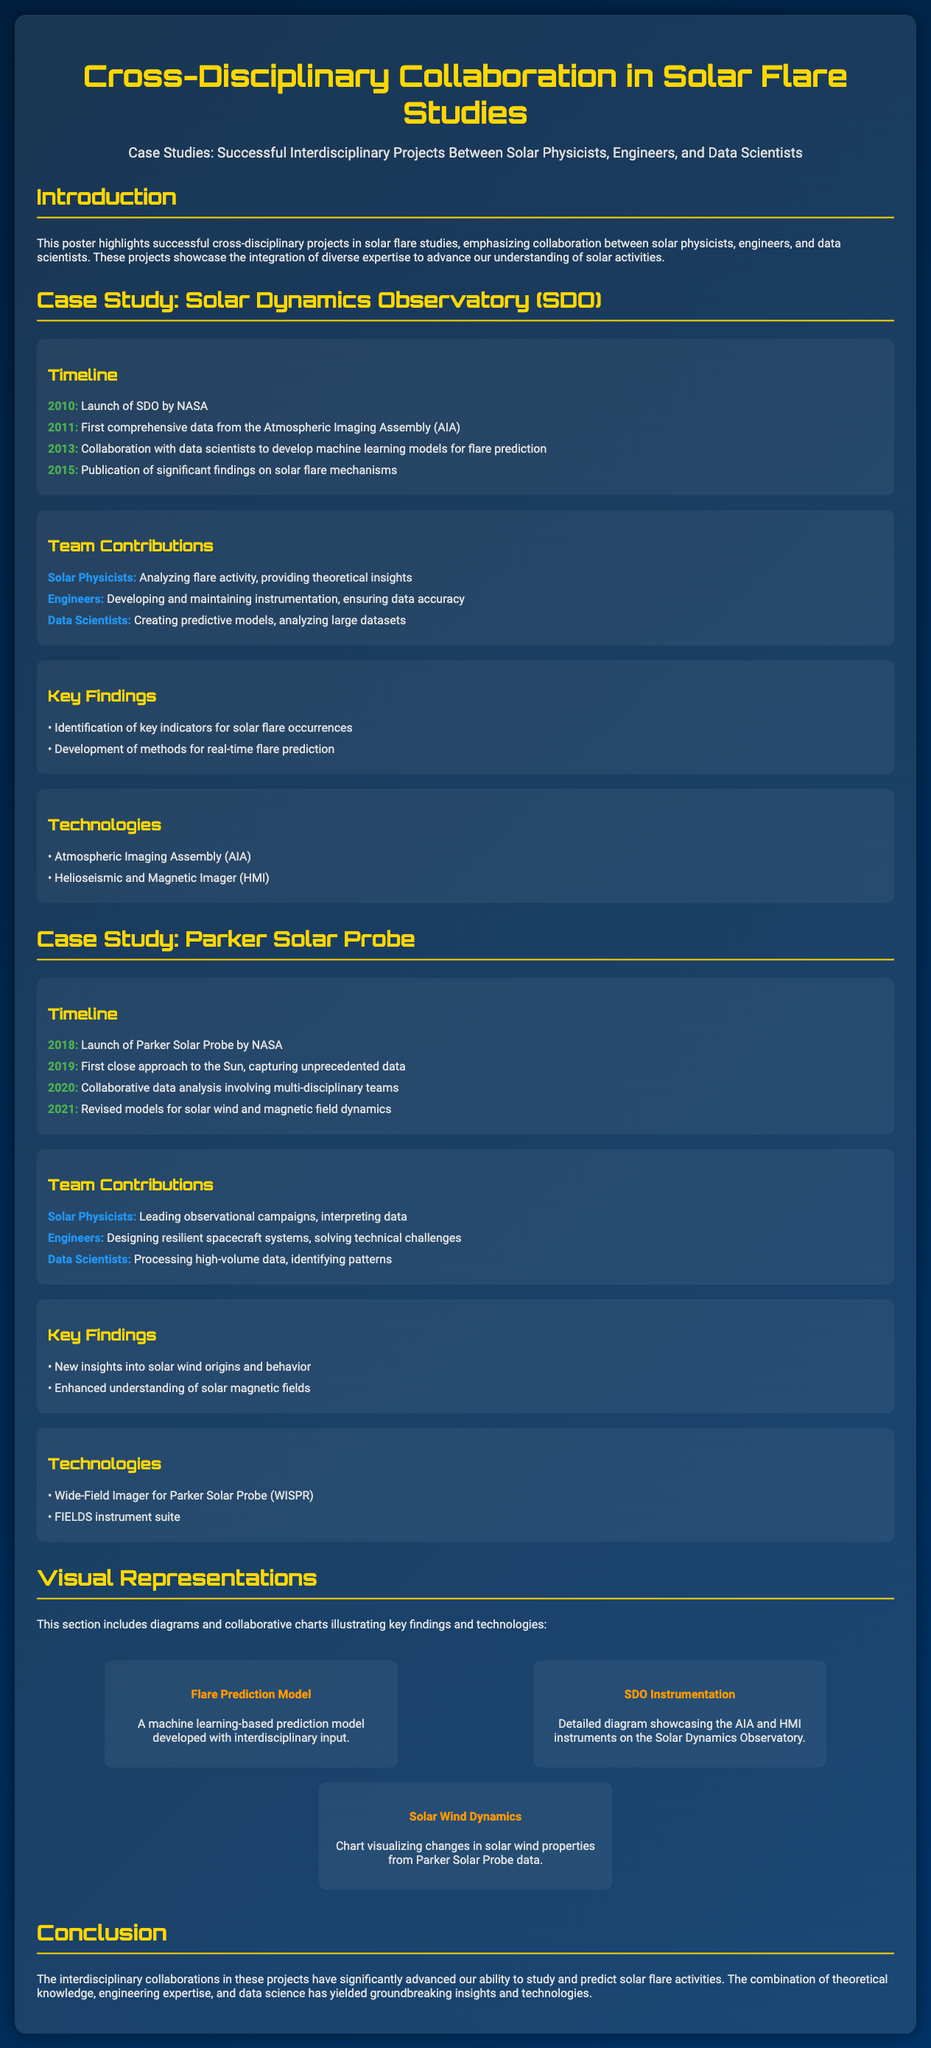what year was the Solar Dynamics Observatory launched? The launch year of the Solar Dynamics Observatory (SDO) is mentioned in the timeline of the case study.
Answer: 2010 which technology is associated with the Parker Solar Probe? The technologies listed under the Parker Solar Probe case study detail the instruments used in the mission.
Answer: FIELDS instrument suite what is one of the key findings of the SDO project? Key findings of the SDO project are presented, highlighting the important results achieved through collaboration.
Answer: Identification of key indicators for solar flare occurrences how many years were between the launch of the Parker Solar Probe and its first close approach to the Sun? The timeline indicates the launch year and the year of the first close approach to calculate the duration.
Answer: 1 year who contributed to the development of predictive models for flare prediction in the SDO case study? The team contributions section specifies the roles of various team members in the SDO project.
Answer: Data Scientists what type of diagram illustrates the flare prediction model? The visual representations section describes the diagrams included in the poster and their focus areas.
Answer: Flare Prediction Model which year saw the publication of significant findings related to solar flares from SDO? The timeline for the SDO case study includes the publication year of notable findings.
Answer: 2015 what is the primary focus of the poster? The poster clearly outlines its main theme in the introduction section.
Answer: Cross-Disciplinary Collaboration 